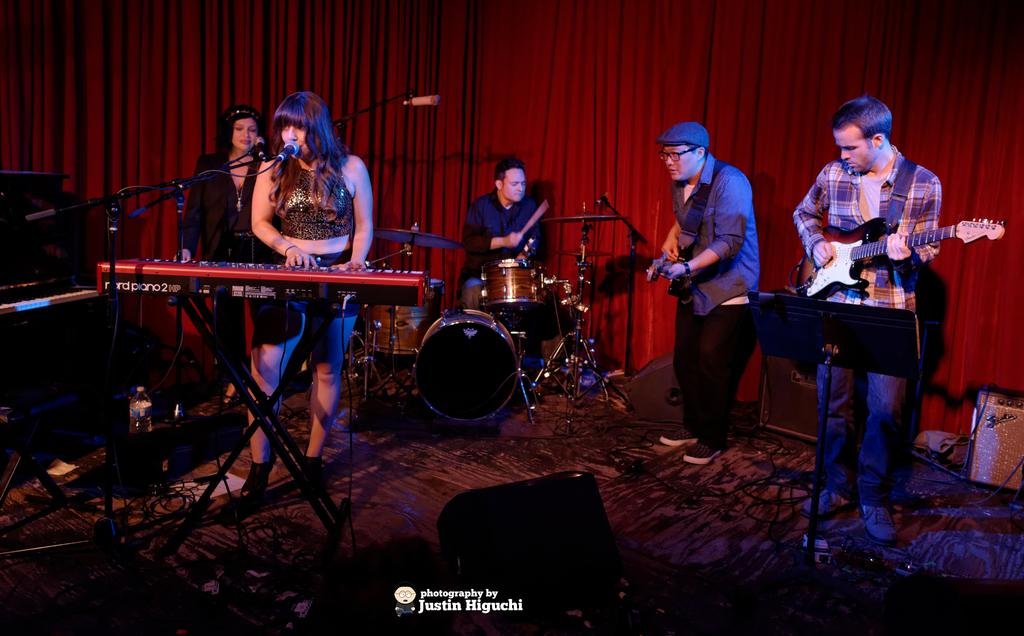What are the people in the image doing? The people in the image are performing. What are they using to perform? They are playing musical instruments, including a piano, drums, and guitar. What can be seen in the background of the image? There is a red curtain in the background of the image. What type of net is being used by the team in the image? There is no net or team present in the image; it features people performing with musical instruments. What station is the performer using to play the guitar in the image? There is no station mentioned or visible in the image; the guitar is being played by a performer without any additional equipment. 